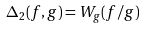Convert formula to latex. <formula><loc_0><loc_0><loc_500><loc_500>\Delta _ { 2 } ( f , g ) = W _ { g } ( f / g )</formula> 